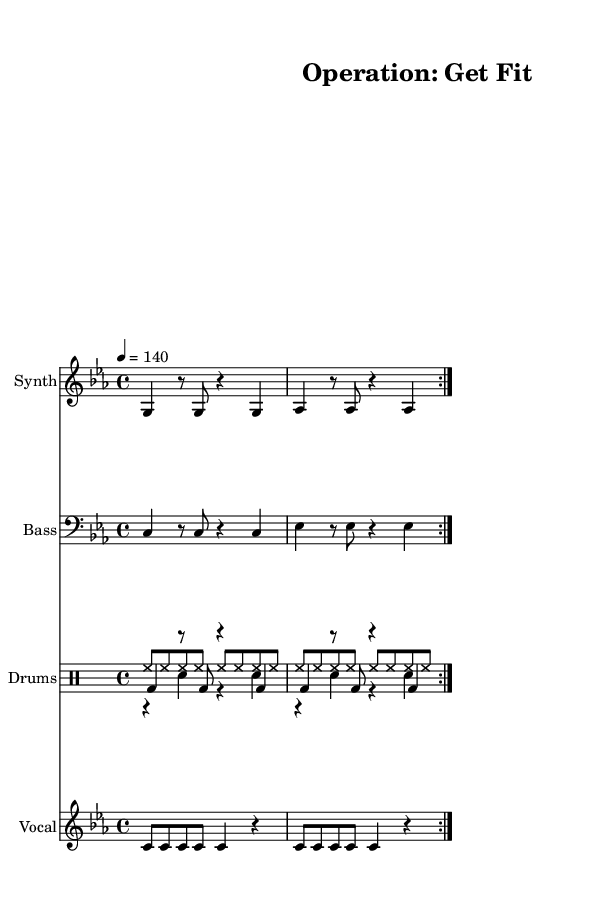What is the key signature of this music? The key signature is C minor, which has three flats (B, E, and A). This can be inferred from the global settings in the music sheet.
Answer: C minor What is the time signature of this music? The time signature is 4/4, which is indicated in the global settings. This means there are four beats in each measure.
Answer: 4/4 What is the tempo marking in this composition? The tempo marking is 140 beats per minute, as specified in the global settings. This indicates that the music is intended to be played at a lively pace.
Answer: 140 How many measures are in the synthesized pattern? The synthesized pattern contains 4 measures. This can be identified by counting the repetitions and sections marked within the score.
Answer: 4 What instruments are featured in this piece? The instruments featured are Synth, Bass, and Drums, which are explicitly indicated in the score's staff sections.
Answer: Synth, Bass, Drums What must the vocalist sing according to the lyrics provided? The vocalist must sing "Ten-hut! It's time to get fit (Sir, yes sir!)" and "Push it to the li -- mit, don't you quit (No ex -- cu -- ses!)", as indicated in the lyrics section of the score.
Answer: "Ten-hut! It's time to get fit (Sir, yes sir!)" and "Push it to the li -- mit, don't you quit (No ex -- cu -- ses!)" 